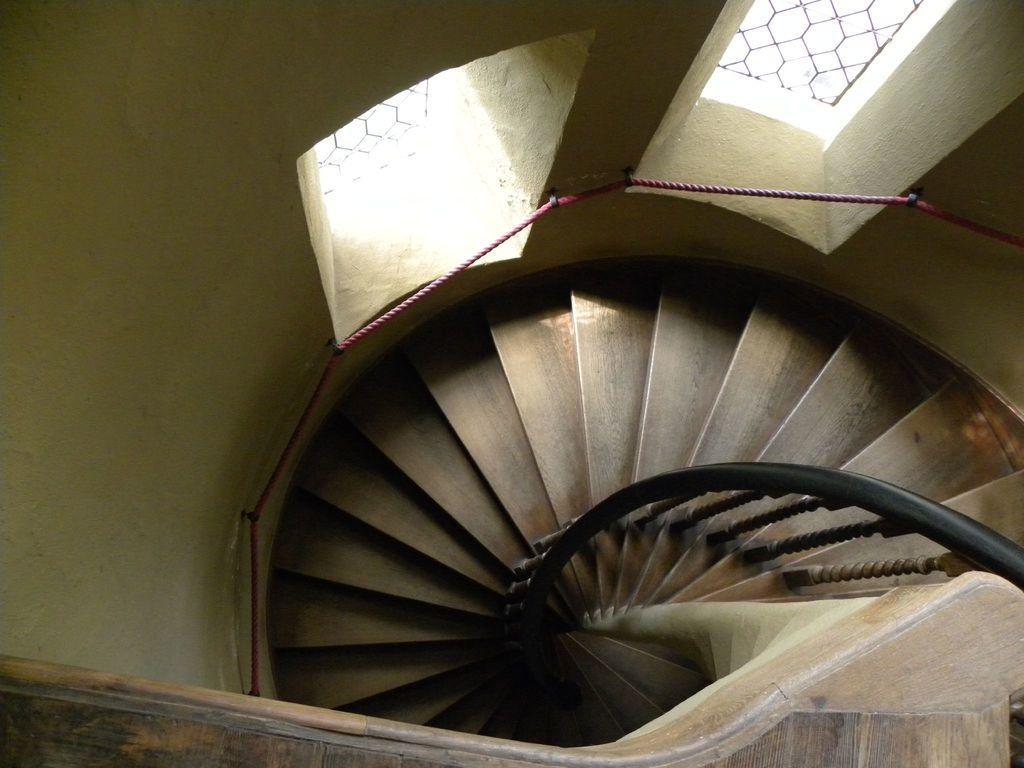In one or two sentences, can you explain what this image depicts? In the image there is a spiral staircase with two windows on the wall. 